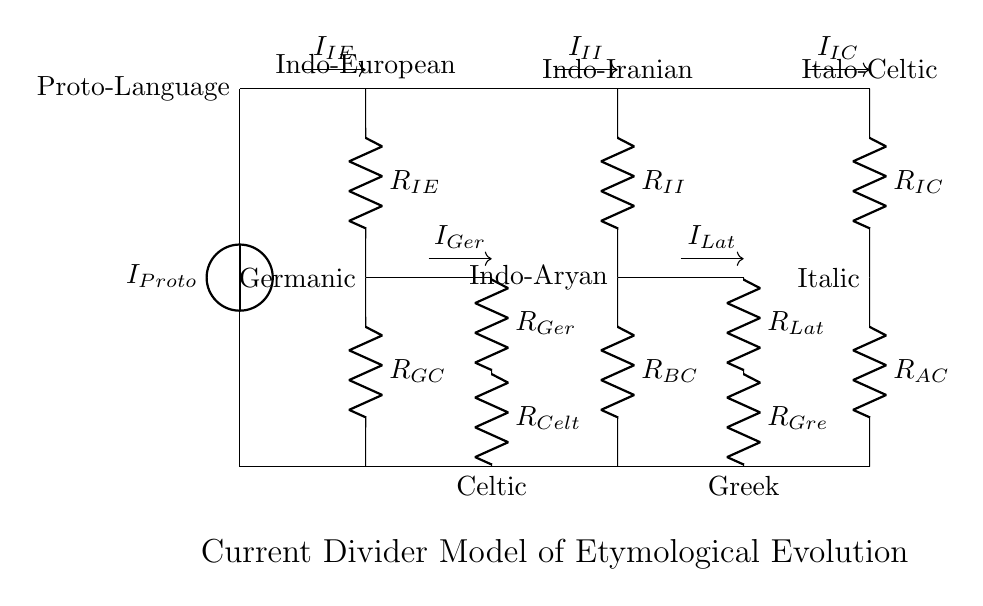What is the main current source in this circuit? The main current source is labeled as I_Proto, indicating that it represents the initial or root language from which other branches of languages evolve.
Answer: I_Proto What are the primary branches from the Proto-Language in the diagram? The primary branches are Indo-European, Indo-Iranian, and Italo-Celtic, which are clearly indicated in the circuit above their respective resistance components.
Answer: Indo-European, Indo-Iranian, Italo-Celtic Which resistance represents the Germanic branch of languages? The resistance labeled R_Ger represents the flow of current associated with the Germanic branch, appearing on the left side of the secondary branches in the circuit.
Answer: R_Ger How many total resistance components are present in the circuit? To find the total number, we count all the resistances labeled in the diagram, which includes R_IE, R_GC, R_II, R_BC, R_IC, R_AC, R_Ger, R_Celt, R_Lat, and R_Gre, leading to a total of 10 resistances.
Answer: 10 Which secondary branch has the resistance labeled R_Lat? The resistance labeled R_Lat is associated with the Latin, which is one of the languages descending from the Indo-Iranian branch in the current divider system.
Answer: Latin What is the total current flowing into the circuit at the source? The total current entering the circuit is represented as I_Proto, which is consistent throughout the circuit as the main current provided to the branches.
Answer: I_Proto Which two branches come from the Indo-European resistance? The two branches that diverge from the Indo-European resistance are the Germanic and Celtic branches, identified through their respective resistances connecting below R_IE.
Answer: Germanic, Celtic 